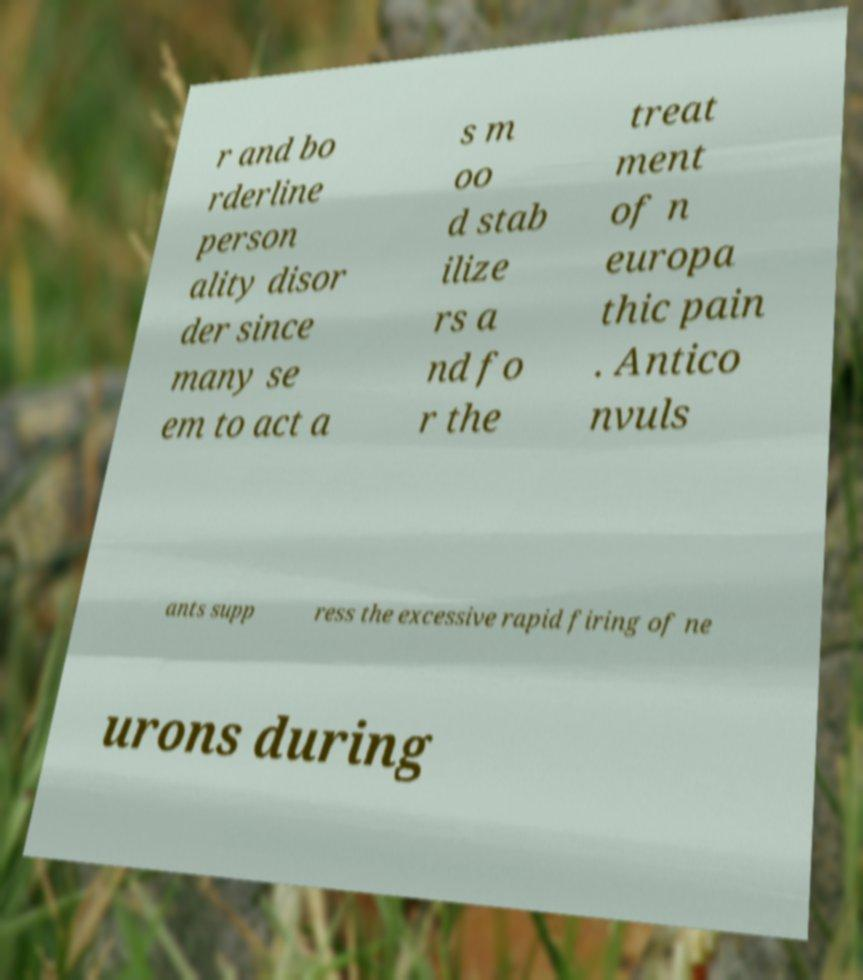Please read and relay the text visible in this image. What does it say? r and bo rderline person ality disor der since many se em to act a s m oo d stab ilize rs a nd fo r the treat ment of n europa thic pain . Antico nvuls ants supp ress the excessive rapid firing of ne urons during 